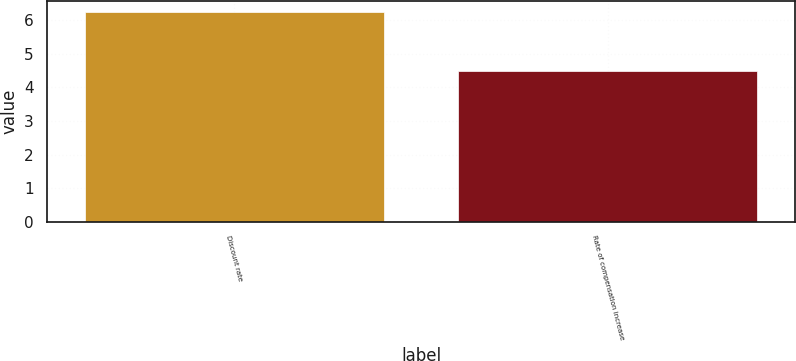<chart> <loc_0><loc_0><loc_500><loc_500><bar_chart><fcel>Discount rate<fcel>Rate of compensation increase<nl><fcel>6.25<fcel>4.5<nl></chart> 